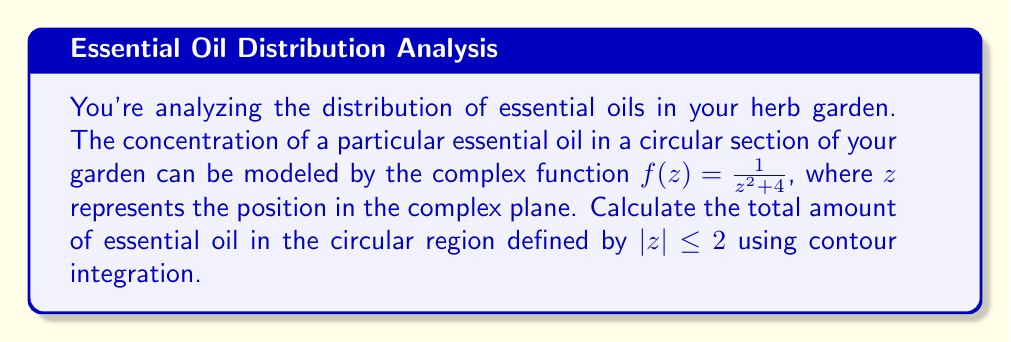Show me your answer to this math problem. To solve this problem, we'll use the Residue Theorem from complex analysis. Here's a step-by-step approach:

1) The Residue Theorem states that for a function $f(z)$ that is analytic except for isolated singularities inside a simple closed contour $C$:

   $$\oint_C f(z) dz = 2\pi i \sum \text{Res}(f, a_k)$$

   where $a_k$ are the singularities of $f(z)$ inside $C$.

2) In our case, $f(z) = \frac{1}{z^2 + 4}$. The singularities of this function are at $z = \pm 2i$.

3) The contour $C$ is the circle $|z| = 2$. Only the singularity at $z = 2i$ lies within this contour.

4) To find the residue at $z = 2i$, we use the formula for a simple pole:

   $$\text{Res}(f, 2i) = \lim_{z \to 2i} (z - 2i)f(z) = \lim_{z \to 2i} \frac{z - 2i}{z^2 + 4} = \frac{1}{4i}$$

5) Applying the Residue Theorem:

   $$\oint_{|z|=2} \frac{1}{z^2 + 4} dz = 2\pi i \cdot \frac{1}{4i} = \frac{\pi}{2}$$

6) This integral represents the total amount of essential oil in the circular region.
Answer: The total amount of essential oil in the circular region defined by $|z| \leq 2$ is $\frac{\pi}{2}$ units. 